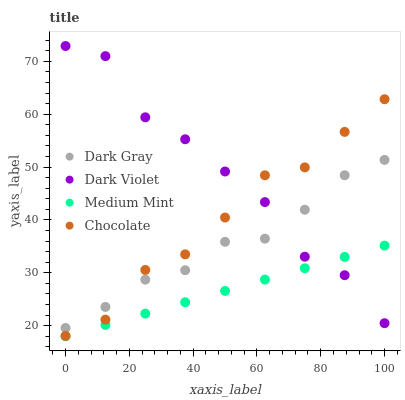Does Medium Mint have the minimum area under the curve?
Answer yes or no. Yes. Does Dark Violet have the maximum area under the curve?
Answer yes or no. Yes. Does Dark Violet have the minimum area under the curve?
Answer yes or no. No. Does Medium Mint have the maximum area under the curve?
Answer yes or no. No. Is Medium Mint the smoothest?
Answer yes or no. Yes. Is Dark Violet the roughest?
Answer yes or no. Yes. Is Dark Violet the smoothest?
Answer yes or no. No. Is Medium Mint the roughest?
Answer yes or no. No. Does Medium Mint have the lowest value?
Answer yes or no. Yes. Does Dark Violet have the lowest value?
Answer yes or no. No. Does Dark Violet have the highest value?
Answer yes or no. Yes. Does Medium Mint have the highest value?
Answer yes or no. No. Is Medium Mint less than Dark Gray?
Answer yes or no. Yes. Is Dark Gray greater than Medium Mint?
Answer yes or no. Yes. Does Chocolate intersect Dark Gray?
Answer yes or no. Yes. Is Chocolate less than Dark Gray?
Answer yes or no. No. Is Chocolate greater than Dark Gray?
Answer yes or no. No. Does Medium Mint intersect Dark Gray?
Answer yes or no. No. 